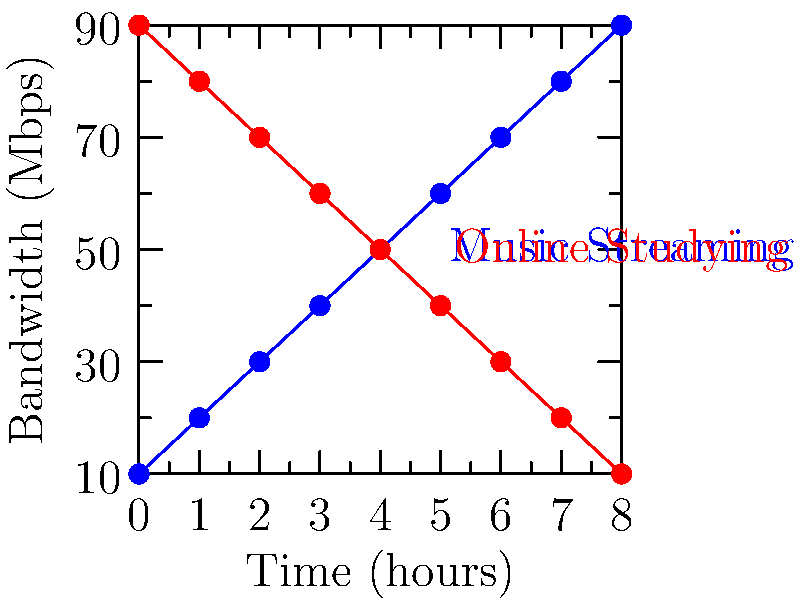The graph shows bandwidth allocation over time for simultaneous music streaming and online studying. At what time (in hours) do the bandwidth allocations for both activities intersect, and what is the corresponding bandwidth at this point? To solve this problem, we need to follow these steps:

1. Observe the graph and identify where the blue line (Music Streaming) and the red line (Online Studying) intersect.

2. The intersection point represents the time when both activities are allocated equal bandwidth.

3. From the graph, we can see that the lines intersect at the 4-hour mark on the x-axis.

4. To find the corresponding bandwidth at this intersection point, we need to look at the y-axis value at the 4-hour mark.

5. The y-axis value at the intersection point is 50 Mbps.

Therefore, the bandwidth allocations for music streaming and online studying intersect at 4 hours, with a bandwidth of 50 Mbps for each activity at this point.
Answer: 4 hours, 50 Mbps 